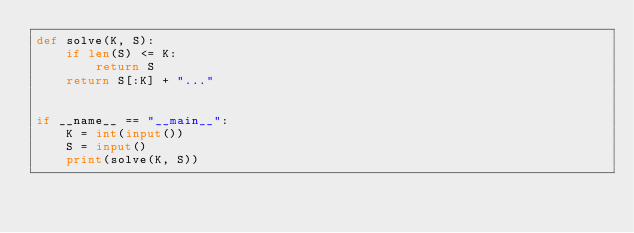<code> <loc_0><loc_0><loc_500><loc_500><_Python_>def solve(K, S):
    if len(S) <= K:
        return S
    return S[:K] + "..."


if __name__ == "__main__":
    K = int(input())
    S = input()
    print(solve(K, S))
</code> 